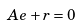<formula> <loc_0><loc_0><loc_500><loc_500>A e + r = 0</formula> 